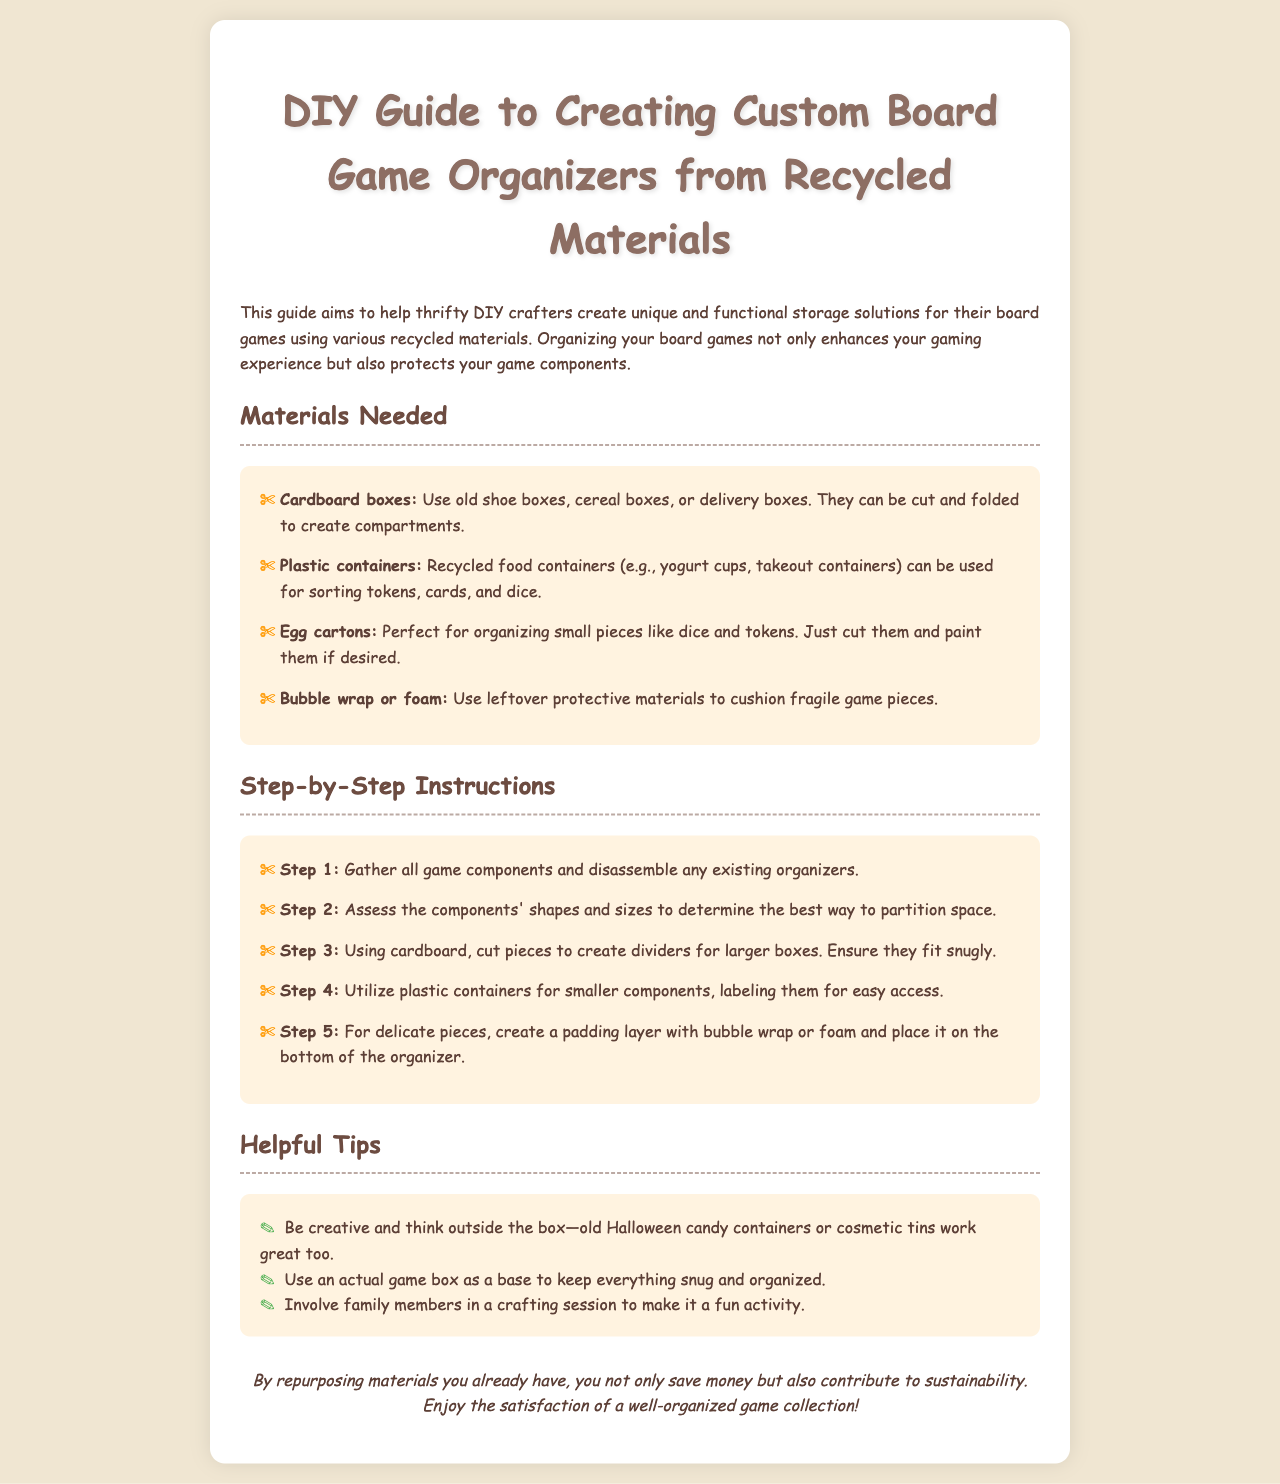What is the primary purpose of this guide? The guide aims to help thrifty DIY crafters create unique and functional storage solutions for their board games using various recycled materials.
Answer: To create storage solutions What material is suggested for small piece organization? The document mentions using egg cartons for organizing small pieces like dice and tokens.
Answer: Egg cartons How many steps are provided in the step-by-step instructions? The step-by-step instructions consist of five distinct steps outlined in the document.
Answer: Five steps What should you use for padding delicate pieces? The guide recommends using bubble wrap or foam to cushion fragile game pieces.
Answer: Bubble wrap or foam What type of materials are emphasized for creating organizers? The document emphasizes using recycled materials as a key component for creating organizers.
Answer: Recycled materials Which item can serve as a base for organization? The guide suggests using an actual game box as a base to keep everything snug and organized.
Answer: An actual game box What is one way to make the crafting process fun? The document mentions involving family members in a crafting session as a way to make it a fun activity.
Answer: Involve family members What color is the document’s background? The background color of the document is described as a light beige.
Answer: Light beige 